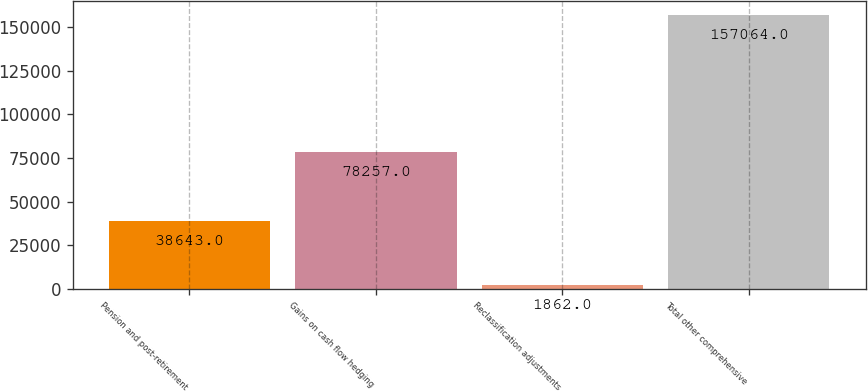<chart> <loc_0><loc_0><loc_500><loc_500><bar_chart><fcel>Pension and post-retirement<fcel>Gains on cash flow hedging<fcel>Reclassification adjustments<fcel>Total other comprehensive<nl><fcel>38643<fcel>78257<fcel>1862<fcel>157064<nl></chart> 